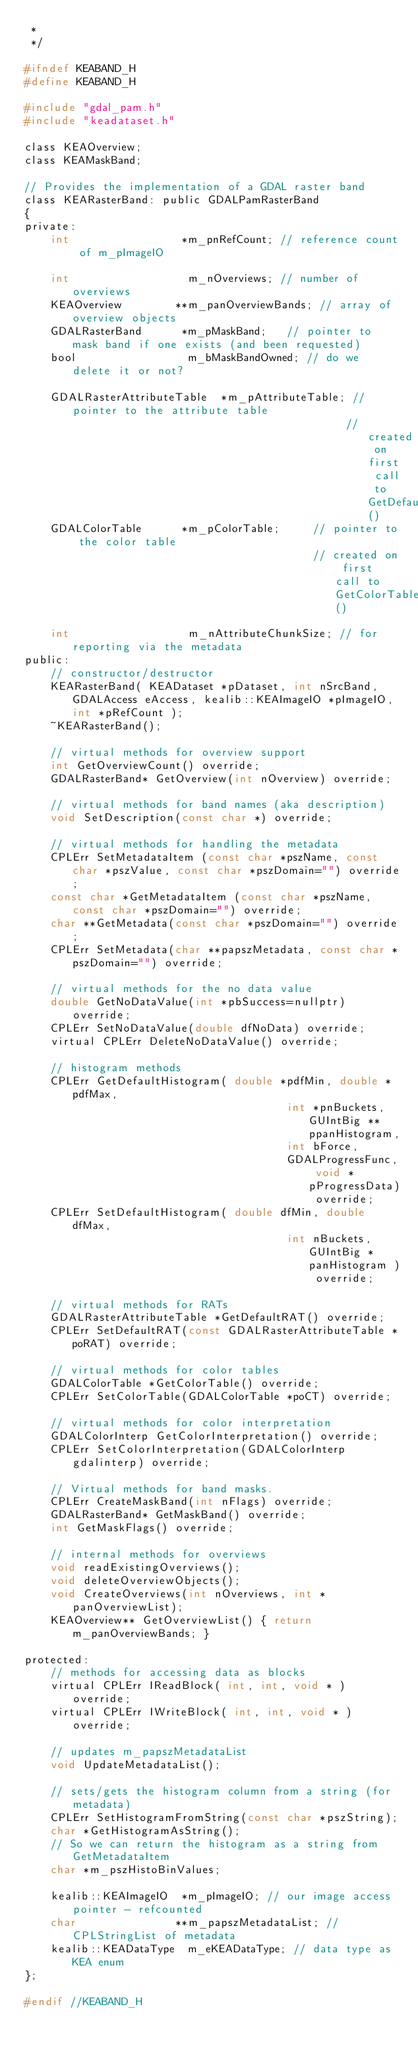Convert code to text. <code><loc_0><loc_0><loc_500><loc_500><_C_> *
 */

#ifndef KEABAND_H
#define KEABAND_H

#include "gdal_pam.h"
#include "keadataset.h"

class KEAOverview;
class KEAMaskBand;

// Provides the implementation of a GDAL raster band
class KEARasterBand: public GDALPamRasterBand
{
private:
    int                 *m_pnRefCount; // reference count of m_pImageIO

    int                  m_nOverviews; // number of overviews
    KEAOverview        **m_panOverviewBands; // array of overview objects
    GDALRasterBand      *m_pMaskBand;   // pointer to mask band if one exists (and been requested)
    bool                 m_bMaskBandOwned; // do we delete it or not?

    GDALRasterAttributeTable  *m_pAttributeTable; // pointer to the attribute table
                                                 // created on first call to GetDefaultRAT()
    GDALColorTable      *m_pColorTable;     // pointer to the color table
                                            // created on first call to GetColorTable()

    int                  m_nAttributeChunkSize; // for reporting via the metadata
public:
    // constructor/destructor
    KEARasterBand( KEADataset *pDataset, int nSrcBand, GDALAccess eAccess, kealib::KEAImageIO *pImageIO, int *pRefCount );
    ~KEARasterBand();

    // virtual methods for overview support
    int GetOverviewCount() override;
    GDALRasterBand* GetOverview(int nOverview) override;

    // virtual methods for band names (aka description)
    void SetDescription(const char *) override;

    // virtual methods for handling the metadata
    CPLErr SetMetadataItem (const char *pszName, const char *pszValue, const char *pszDomain="") override;
    const char *GetMetadataItem (const char *pszName, const char *pszDomain="") override;
    char **GetMetadata(const char *pszDomain="") override;
    CPLErr SetMetadata(char **papszMetadata, const char *pszDomain="") override;

    // virtual methods for the no data value
    double GetNoDataValue(int *pbSuccess=nullptr) override;
    CPLErr SetNoDataValue(double dfNoData) override;
    virtual CPLErr DeleteNoDataValue() override;

    // histogram methods
    CPLErr GetDefaultHistogram( double *pdfMin, double *pdfMax,
                                        int *pnBuckets, GUIntBig ** ppanHistogram,
                                        int bForce,
                                        GDALProgressFunc, void *pProgressData) override;
    CPLErr SetDefaultHistogram( double dfMin, double dfMax,
                                        int nBuckets, GUIntBig *panHistogram ) override;

    // virtual methods for RATs
    GDALRasterAttributeTable *GetDefaultRAT() override;
    CPLErr SetDefaultRAT(const GDALRasterAttributeTable *poRAT) override;

    // virtual methods for color tables
    GDALColorTable *GetColorTable() override;
    CPLErr SetColorTable(GDALColorTable *poCT) override;

    // virtual methods for color interpretation
    GDALColorInterp GetColorInterpretation() override;
    CPLErr SetColorInterpretation(GDALColorInterp gdalinterp) override;

    // Virtual methods for band masks.
    CPLErr CreateMaskBand(int nFlags) override;
    GDALRasterBand* GetMaskBand() override;
    int GetMaskFlags() override;

    // internal methods for overviews
    void readExistingOverviews();
    void deleteOverviewObjects();
    void CreateOverviews(int nOverviews, int *panOverviewList);
    KEAOverview** GetOverviewList() { return m_panOverviewBands; }

protected:
    // methods for accessing data as blocks
    virtual CPLErr IReadBlock( int, int, void * ) override;
    virtual CPLErr IWriteBlock( int, int, void * ) override;

    // updates m_papszMetadataList
    void UpdateMetadataList();

    // sets/gets the histogram column from a string (for metadata)
    CPLErr SetHistogramFromString(const char *pszString);
    char *GetHistogramAsString();
    // So we can return the histogram as a string from GetMetadataItem
    char *m_pszHistoBinValues;

    kealib::KEAImageIO  *m_pImageIO; // our image access pointer - refcounted
    char               **m_papszMetadataList; // CPLStringList of metadata
    kealib::KEADataType  m_eKEADataType; // data type as KEA enum
};

#endif //KEABAND_H
</code> 